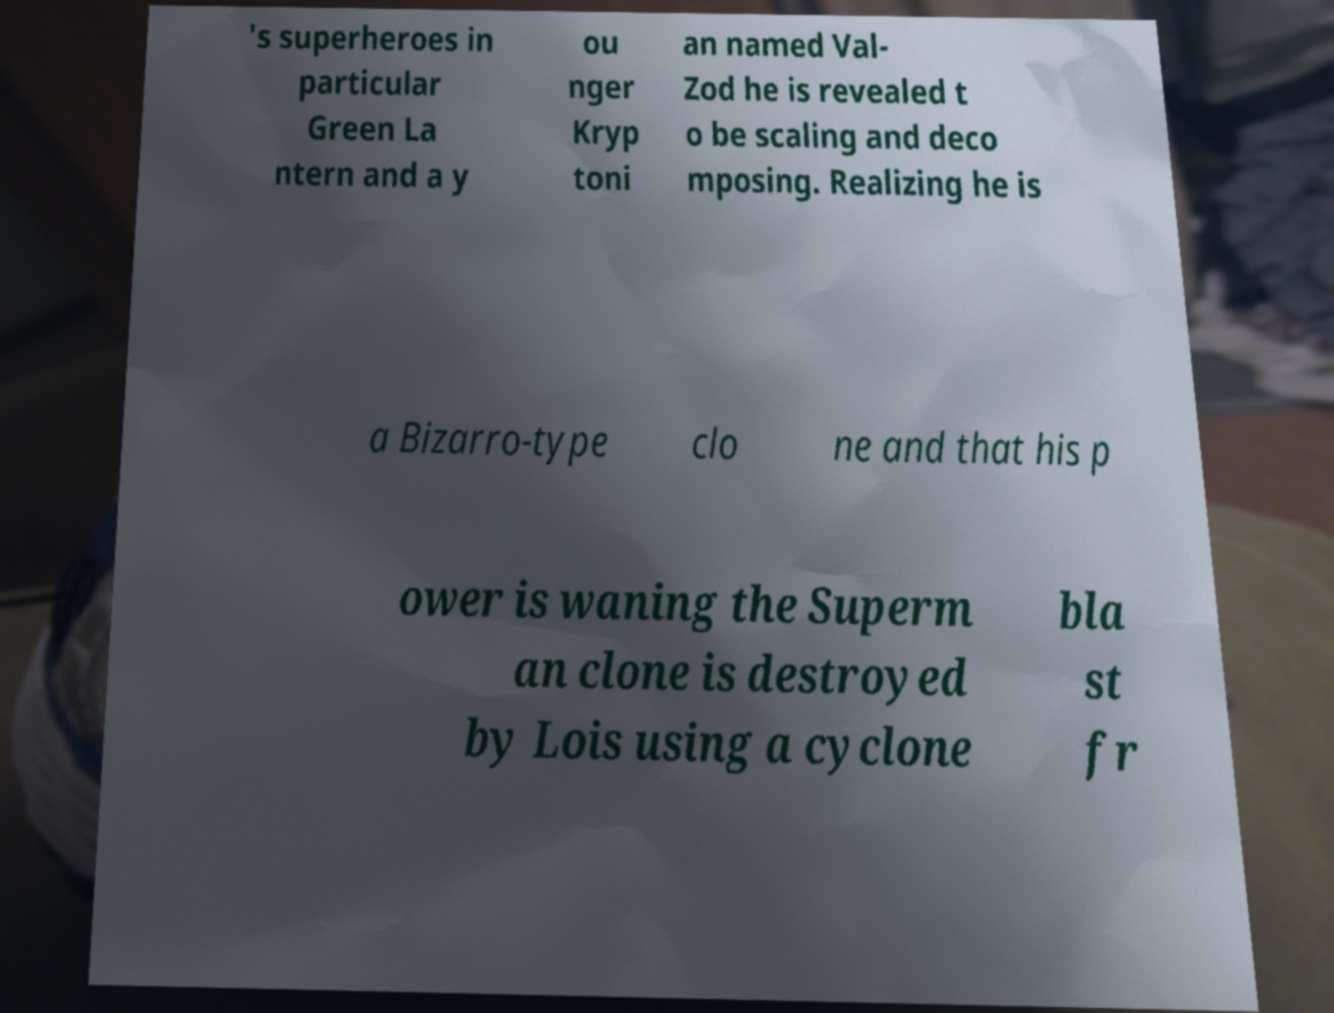Could you assist in decoding the text presented in this image and type it out clearly? 's superheroes in particular Green La ntern and a y ou nger Kryp toni an named Val- Zod he is revealed t o be scaling and deco mposing. Realizing he is a Bizarro-type clo ne and that his p ower is waning the Superm an clone is destroyed by Lois using a cyclone bla st fr 